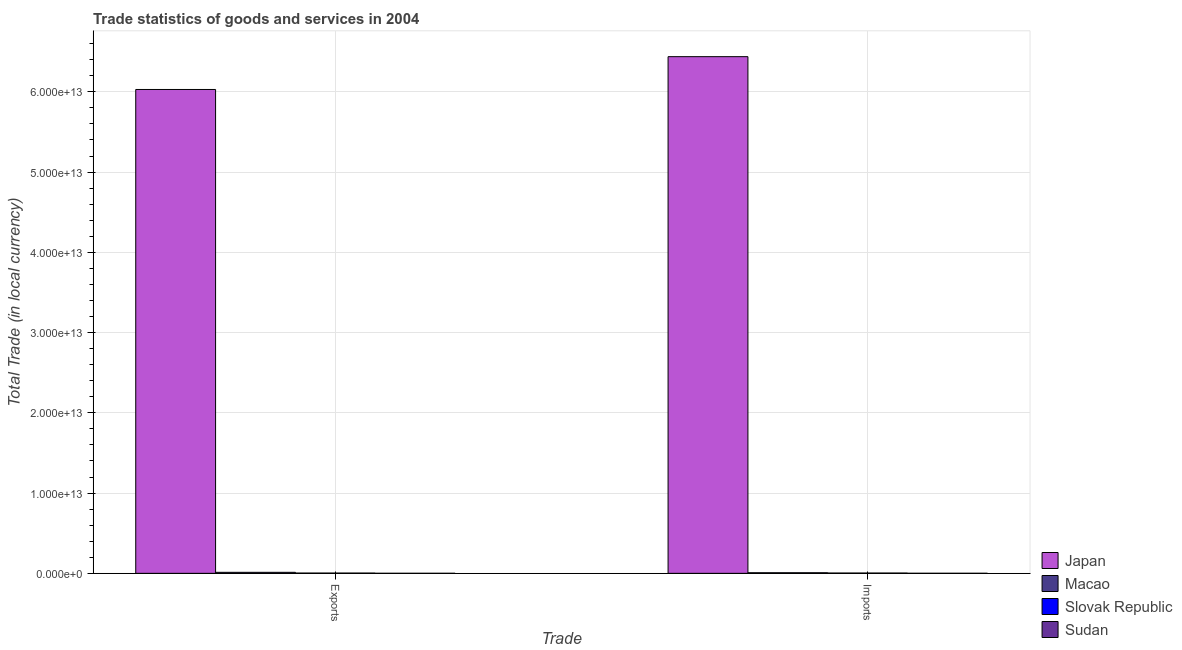How many groups of bars are there?
Give a very brief answer. 2. Are the number of bars on each tick of the X-axis equal?
Offer a very short reply. Yes. What is the label of the 1st group of bars from the left?
Provide a succinct answer. Exports. What is the imports of goods and services in Macao?
Keep it short and to the point. 7.45e+1. Across all countries, what is the maximum export of goods and services?
Give a very brief answer. 6.03e+13. Across all countries, what is the minimum export of goods and services?
Your answer should be very brief. 3.97e+09. In which country was the imports of goods and services minimum?
Make the answer very short. Sudan. What is the total imports of goods and services in the graph?
Your response must be concise. 6.45e+13. What is the difference between the export of goods and services in Slovak Republic and that in Macao?
Your answer should be very brief. -9.38e+1. What is the difference between the export of goods and services in Japan and the imports of goods and services in Macao?
Your answer should be very brief. 6.02e+13. What is the average imports of goods and services per country?
Provide a succinct answer. 1.61e+13. What is the difference between the imports of goods and services and export of goods and services in Japan?
Provide a succinct answer. 4.09e+12. What is the ratio of the imports of goods and services in Sudan to that in Slovak Republic?
Provide a succinct answer. 0.16. In how many countries, is the export of goods and services greater than the average export of goods and services taken over all countries?
Provide a succinct answer. 1. What does the 2nd bar from the left in Exports represents?
Ensure brevity in your answer.  Macao. What does the 1st bar from the right in Imports represents?
Provide a short and direct response. Sudan. How many bars are there?
Ensure brevity in your answer.  8. Are all the bars in the graph horizontal?
Offer a terse response. No. What is the difference between two consecutive major ticks on the Y-axis?
Give a very brief answer. 1.00e+13. Where does the legend appear in the graph?
Your response must be concise. Bottom right. How many legend labels are there?
Your answer should be compact. 4. How are the legend labels stacked?
Make the answer very short. Vertical. What is the title of the graph?
Make the answer very short. Trade statistics of goods and services in 2004. What is the label or title of the X-axis?
Offer a very short reply. Trade. What is the label or title of the Y-axis?
Make the answer very short. Total Trade (in local currency). What is the Total Trade (in local currency) of Japan in Exports?
Make the answer very short. 6.03e+13. What is the Total Trade (in local currency) in Macao in Exports?
Give a very brief answer. 1.26e+11. What is the Total Trade (in local currency) of Slovak Republic in Exports?
Provide a short and direct response. 3.27e+1. What is the Total Trade (in local currency) of Sudan in Exports?
Your answer should be compact. 3.97e+09. What is the Total Trade (in local currency) in Japan in Imports?
Ensure brevity in your answer.  6.44e+13. What is the Total Trade (in local currency) of Macao in Imports?
Provide a short and direct response. 7.45e+1. What is the Total Trade (in local currency) of Slovak Republic in Imports?
Offer a very short reply. 3.61e+1. What is the Total Trade (in local currency) of Sudan in Imports?
Your answer should be compact. 5.89e+09. Across all Trade, what is the maximum Total Trade (in local currency) in Japan?
Provide a succinct answer. 6.44e+13. Across all Trade, what is the maximum Total Trade (in local currency) in Macao?
Make the answer very short. 1.26e+11. Across all Trade, what is the maximum Total Trade (in local currency) of Slovak Republic?
Your response must be concise. 3.61e+1. Across all Trade, what is the maximum Total Trade (in local currency) in Sudan?
Ensure brevity in your answer.  5.89e+09. Across all Trade, what is the minimum Total Trade (in local currency) in Japan?
Your answer should be compact. 6.03e+13. Across all Trade, what is the minimum Total Trade (in local currency) in Macao?
Make the answer very short. 7.45e+1. Across all Trade, what is the minimum Total Trade (in local currency) of Slovak Republic?
Your answer should be very brief. 3.27e+1. Across all Trade, what is the minimum Total Trade (in local currency) in Sudan?
Your answer should be very brief. 3.97e+09. What is the total Total Trade (in local currency) in Japan in the graph?
Offer a terse response. 1.25e+14. What is the total Total Trade (in local currency) of Macao in the graph?
Offer a very short reply. 2.01e+11. What is the total Total Trade (in local currency) in Slovak Republic in the graph?
Give a very brief answer. 6.88e+1. What is the total Total Trade (in local currency) of Sudan in the graph?
Ensure brevity in your answer.  9.85e+09. What is the difference between the Total Trade (in local currency) in Japan in Exports and that in Imports?
Your answer should be very brief. -4.09e+12. What is the difference between the Total Trade (in local currency) of Macao in Exports and that in Imports?
Offer a terse response. 5.19e+1. What is the difference between the Total Trade (in local currency) in Slovak Republic in Exports and that in Imports?
Make the answer very short. -3.41e+09. What is the difference between the Total Trade (in local currency) in Sudan in Exports and that in Imports?
Ensure brevity in your answer.  -1.92e+09. What is the difference between the Total Trade (in local currency) in Japan in Exports and the Total Trade (in local currency) in Macao in Imports?
Your answer should be compact. 6.02e+13. What is the difference between the Total Trade (in local currency) in Japan in Exports and the Total Trade (in local currency) in Slovak Republic in Imports?
Make the answer very short. 6.03e+13. What is the difference between the Total Trade (in local currency) in Japan in Exports and the Total Trade (in local currency) in Sudan in Imports?
Ensure brevity in your answer.  6.03e+13. What is the difference between the Total Trade (in local currency) of Macao in Exports and the Total Trade (in local currency) of Slovak Republic in Imports?
Give a very brief answer. 9.04e+1. What is the difference between the Total Trade (in local currency) in Macao in Exports and the Total Trade (in local currency) in Sudan in Imports?
Your response must be concise. 1.21e+11. What is the difference between the Total Trade (in local currency) of Slovak Republic in Exports and the Total Trade (in local currency) of Sudan in Imports?
Make the answer very short. 2.68e+1. What is the average Total Trade (in local currency) of Japan per Trade?
Keep it short and to the point. 6.23e+13. What is the average Total Trade (in local currency) in Macao per Trade?
Provide a short and direct response. 1.01e+11. What is the average Total Trade (in local currency) of Slovak Republic per Trade?
Your response must be concise. 3.44e+1. What is the average Total Trade (in local currency) of Sudan per Trade?
Provide a short and direct response. 4.93e+09. What is the difference between the Total Trade (in local currency) of Japan and Total Trade (in local currency) of Macao in Exports?
Ensure brevity in your answer.  6.02e+13. What is the difference between the Total Trade (in local currency) in Japan and Total Trade (in local currency) in Slovak Republic in Exports?
Give a very brief answer. 6.03e+13. What is the difference between the Total Trade (in local currency) of Japan and Total Trade (in local currency) of Sudan in Exports?
Ensure brevity in your answer.  6.03e+13. What is the difference between the Total Trade (in local currency) in Macao and Total Trade (in local currency) in Slovak Republic in Exports?
Your answer should be compact. 9.38e+1. What is the difference between the Total Trade (in local currency) in Macao and Total Trade (in local currency) in Sudan in Exports?
Your answer should be compact. 1.23e+11. What is the difference between the Total Trade (in local currency) in Slovak Republic and Total Trade (in local currency) in Sudan in Exports?
Provide a succinct answer. 2.87e+1. What is the difference between the Total Trade (in local currency) in Japan and Total Trade (in local currency) in Macao in Imports?
Make the answer very short. 6.43e+13. What is the difference between the Total Trade (in local currency) of Japan and Total Trade (in local currency) of Slovak Republic in Imports?
Provide a short and direct response. 6.43e+13. What is the difference between the Total Trade (in local currency) of Japan and Total Trade (in local currency) of Sudan in Imports?
Provide a succinct answer. 6.44e+13. What is the difference between the Total Trade (in local currency) in Macao and Total Trade (in local currency) in Slovak Republic in Imports?
Your response must be concise. 3.84e+1. What is the difference between the Total Trade (in local currency) in Macao and Total Trade (in local currency) in Sudan in Imports?
Provide a short and direct response. 6.87e+1. What is the difference between the Total Trade (in local currency) in Slovak Republic and Total Trade (in local currency) in Sudan in Imports?
Provide a succinct answer. 3.02e+1. What is the ratio of the Total Trade (in local currency) in Japan in Exports to that in Imports?
Your answer should be compact. 0.94. What is the ratio of the Total Trade (in local currency) in Macao in Exports to that in Imports?
Offer a terse response. 1.7. What is the ratio of the Total Trade (in local currency) in Slovak Republic in Exports to that in Imports?
Offer a very short reply. 0.91. What is the ratio of the Total Trade (in local currency) in Sudan in Exports to that in Imports?
Your answer should be very brief. 0.67. What is the difference between the highest and the second highest Total Trade (in local currency) in Japan?
Ensure brevity in your answer.  4.09e+12. What is the difference between the highest and the second highest Total Trade (in local currency) of Macao?
Offer a terse response. 5.19e+1. What is the difference between the highest and the second highest Total Trade (in local currency) in Slovak Republic?
Your answer should be compact. 3.41e+09. What is the difference between the highest and the second highest Total Trade (in local currency) of Sudan?
Your response must be concise. 1.92e+09. What is the difference between the highest and the lowest Total Trade (in local currency) in Japan?
Offer a terse response. 4.09e+12. What is the difference between the highest and the lowest Total Trade (in local currency) of Macao?
Ensure brevity in your answer.  5.19e+1. What is the difference between the highest and the lowest Total Trade (in local currency) of Slovak Republic?
Ensure brevity in your answer.  3.41e+09. What is the difference between the highest and the lowest Total Trade (in local currency) of Sudan?
Provide a short and direct response. 1.92e+09. 